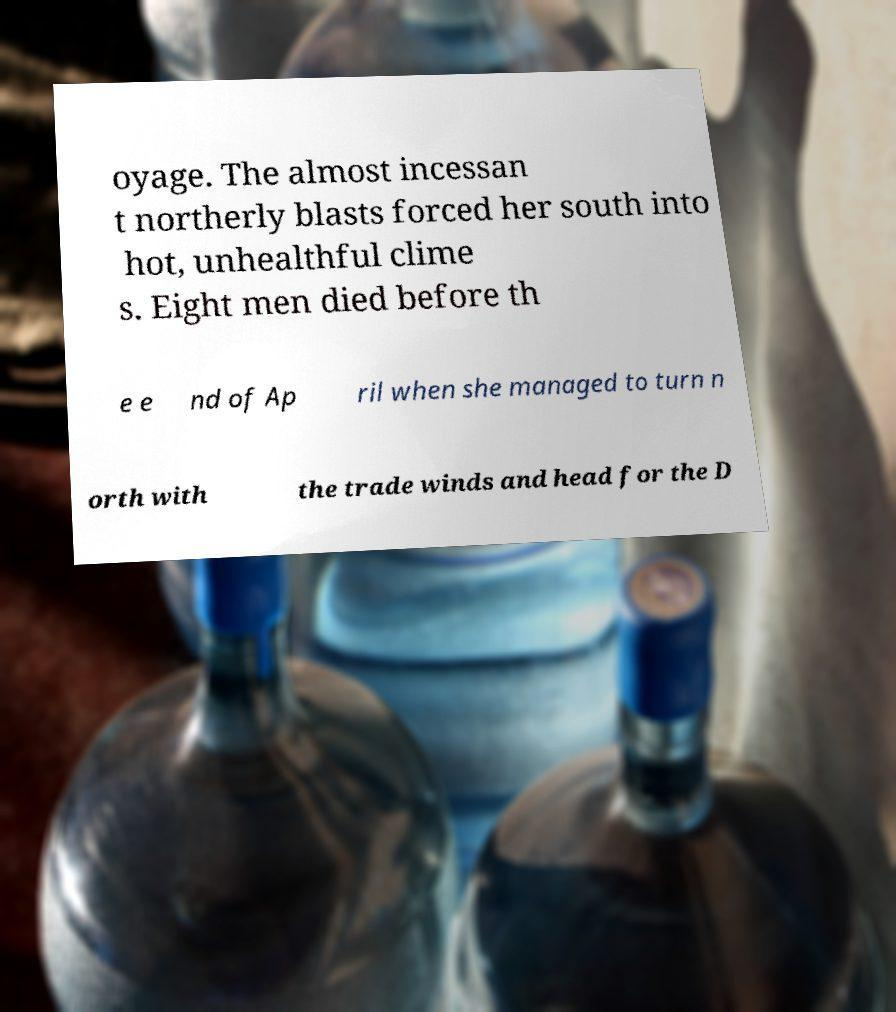What messages or text are displayed in this image? I need them in a readable, typed format. oyage. The almost incessan t northerly blasts forced her south into hot, unhealthful clime s. Eight men died before th e e nd of Ap ril when she managed to turn n orth with the trade winds and head for the D 